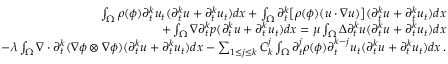Convert formula to latex. <formula><loc_0><loc_0><loc_500><loc_500>\begin{array} { r } { \int _ { \Omega } \rho ( \phi ) \partial _ { t } ^ { k } u _ { t } ( \partial _ { t } ^ { k } u + \partial _ { t } ^ { k } u _ { t } ) d x + \int _ { \Omega } \partial _ { t } ^ { k } \left [ \rho ( \phi ) ( u \cdot \nabla u ) \right ] ( \partial _ { t } ^ { k } u + \partial _ { t } ^ { k } u _ { t } ) d x } \\ { + \int _ { \Omega } \nabla \partial _ { t } ^ { k } p ( \partial _ { t } ^ { k } u + \partial _ { t } ^ { k } u _ { t } ) d x = \mu \int _ { \Omega } \Delta \partial _ { t } ^ { k } u ( \partial _ { t } ^ { k } u + \partial _ { t } ^ { k } u _ { t } ) d x } \\ { - \lambda \int _ { \Omega } \nabla \cdot \partial _ { t } ^ { k } ( \nabla \phi \otimes \nabla \phi ) ( \partial _ { t } ^ { k } u + \partial _ { t } ^ { k } u _ { t } ) d x - \sum _ { 1 \leq j \leq k } C _ { k } ^ { j } \int _ { \Omega } \partial _ { t } ^ { j } \rho ( \phi ) \partial _ { t } ^ { k - j } u _ { t } ( \partial _ { t } ^ { k } u + \partial _ { t } ^ { k } u _ { t } ) d x \, . } \end{array}</formula> 